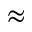<formula> <loc_0><loc_0><loc_500><loc_500>\approx</formula> 